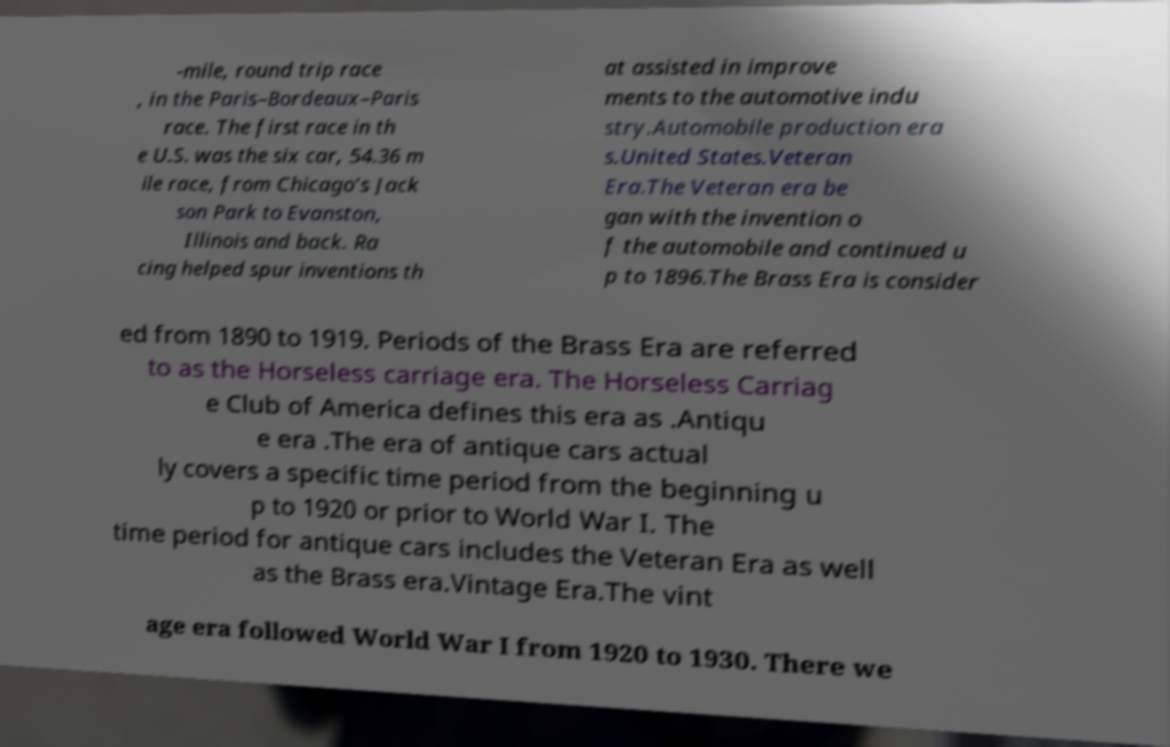I need the written content from this picture converted into text. Can you do that? -mile, round trip race , in the Paris–Bordeaux–Paris race. The first race in th e U.S. was the six car, 54.36 m ile race, from Chicago’s Jack son Park to Evanston, Illinois and back. Ra cing helped spur inventions th at assisted in improve ments to the automotive indu stry.Automobile production era s.United States.Veteran Era.The Veteran era be gan with the invention o f the automobile and continued u p to 1896.The Brass Era is consider ed from 1890 to 1919. Periods of the Brass Era are referred to as the Horseless carriage era. The Horseless Carriag e Club of America defines this era as .Antiqu e era .The era of antique cars actual ly covers a specific time period from the beginning u p to 1920 or prior to World War I. The time period for antique cars includes the Veteran Era as well as the Brass era.Vintage Era.The vint age era followed World War I from 1920 to 1930. There we 